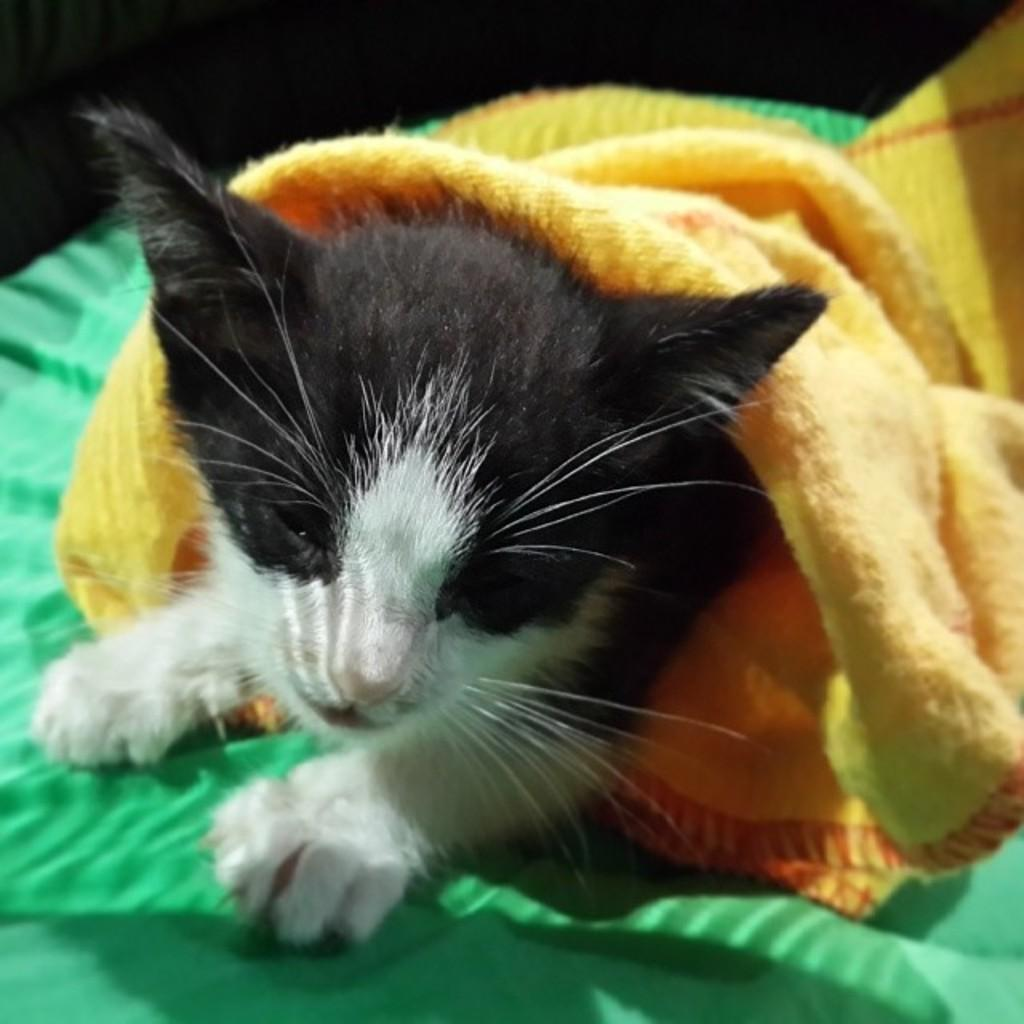What type of animal is in the image? There is a cat in the image. What is the cat sitting on? The cat is on a green cloth. Is there any other cloth visible in the image? Yes, there is a yellow cloth on top of the green cloth. What direction is the cat facing in the image? The direction the cat is facing cannot be determined from the image. What type of weather is present in the image? The image does not provide any information about the weather, such as winter or sleet. 